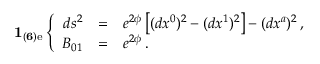Convert formula to latex. <formula><loc_0><loc_0><loc_500><loc_500>{ 1 _ { ( 6 ) e } } \left \{ \begin{array} { r c l } { { d s ^ { 2 } } } & { = } & { { e ^ { 2 { \phi } } \left [ ( d x ^ { 0 } ) ^ { 2 } - ( d x ^ { 1 } ) ^ { 2 } \right ] - ( d x ^ { a } ) ^ { 2 } \, , } } \\ { { { B } _ { 0 1 } } } & { = } & { { e ^ { 2 { \phi } } \, . } } \end{array}</formula> 